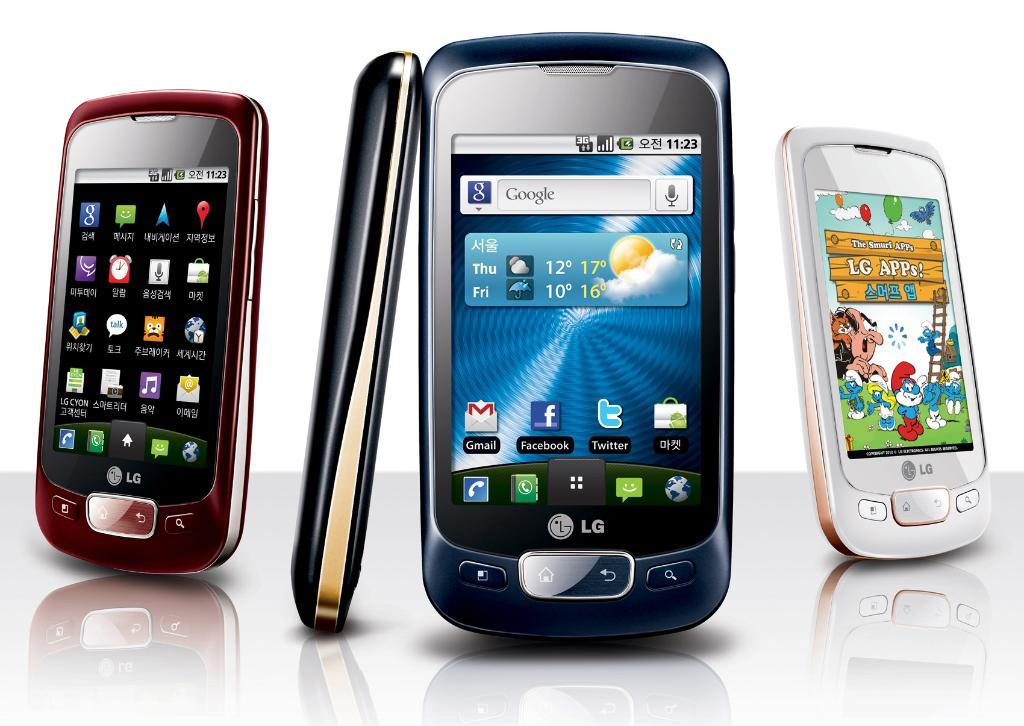<image>
Present a compact description of the photo's key features. A few LG brand phones are lined up together. 